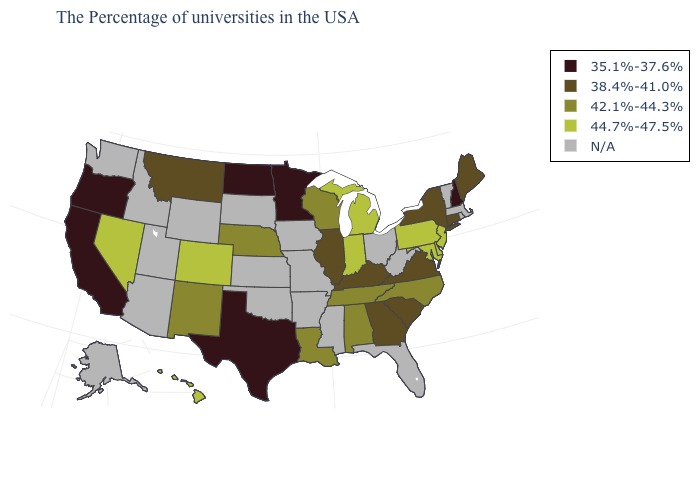Among the states that border Maine , which have the highest value?
Give a very brief answer. New Hampshire. What is the value of New York?
Quick response, please. 38.4%-41.0%. What is the value of Montana?
Keep it brief. 38.4%-41.0%. What is the lowest value in the USA?
Concise answer only. 35.1%-37.6%. Does Georgia have the highest value in the USA?
Give a very brief answer. No. Does the map have missing data?
Give a very brief answer. Yes. Among the states that border Kansas , which have the lowest value?
Concise answer only. Nebraska. What is the highest value in the West ?
Concise answer only. 44.7%-47.5%. Does the first symbol in the legend represent the smallest category?
Keep it brief. Yes. Name the states that have a value in the range 44.7%-47.5%?
Keep it brief. New Jersey, Delaware, Maryland, Pennsylvania, Michigan, Indiana, Colorado, Nevada, Hawaii. What is the value of Arkansas?
Short answer required. N/A. Does the map have missing data?
Concise answer only. Yes. Name the states that have a value in the range N/A?
Answer briefly. Massachusetts, Rhode Island, Vermont, West Virginia, Ohio, Florida, Mississippi, Missouri, Arkansas, Iowa, Kansas, Oklahoma, South Dakota, Wyoming, Utah, Arizona, Idaho, Washington, Alaska. Among the states that border Arizona , which have the highest value?
Answer briefly. Colorado, Nevada. 